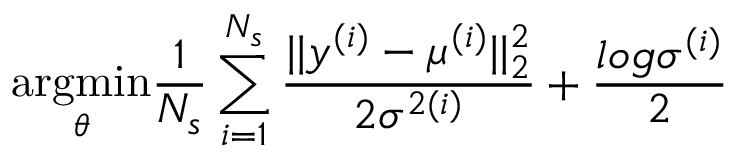<formula> <loc_0><loc_0><loc_500><loc_500>\underset { \theta } { \arg \min } \frac { 1 } { N _ { s } } \sum _ { i = 1 } ^ { N _ { s } } \frac { | | y ^ { ( i ) } - \mu ^ { ( i ) } | | _ { 2 } ^ { 2 } } { 2 \sigma ^ { 2 ( i ) } } + \frac { \log \sigma ^ { ( i ) } } { 2 }</formula> 